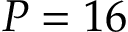<formula> <loc_0><loc_0><loc_500><loc_500>P = 1 6</formula> 